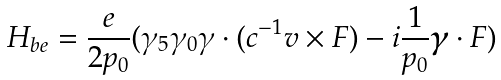Convert formula to latex. <formula><loc_0><loc_0><loc_500><loc_500>H _ { b e } = \frac { e } { 2 p _ { 0 } } ( \gamma _ { 5 } \gamma _ { 0 } \gamma \cdot ( c ^ { - 1 } v \times F ) - i \frac { 1 } { p _ { 0 } } \boldsymbol \gamma \cdot F )</formula> 